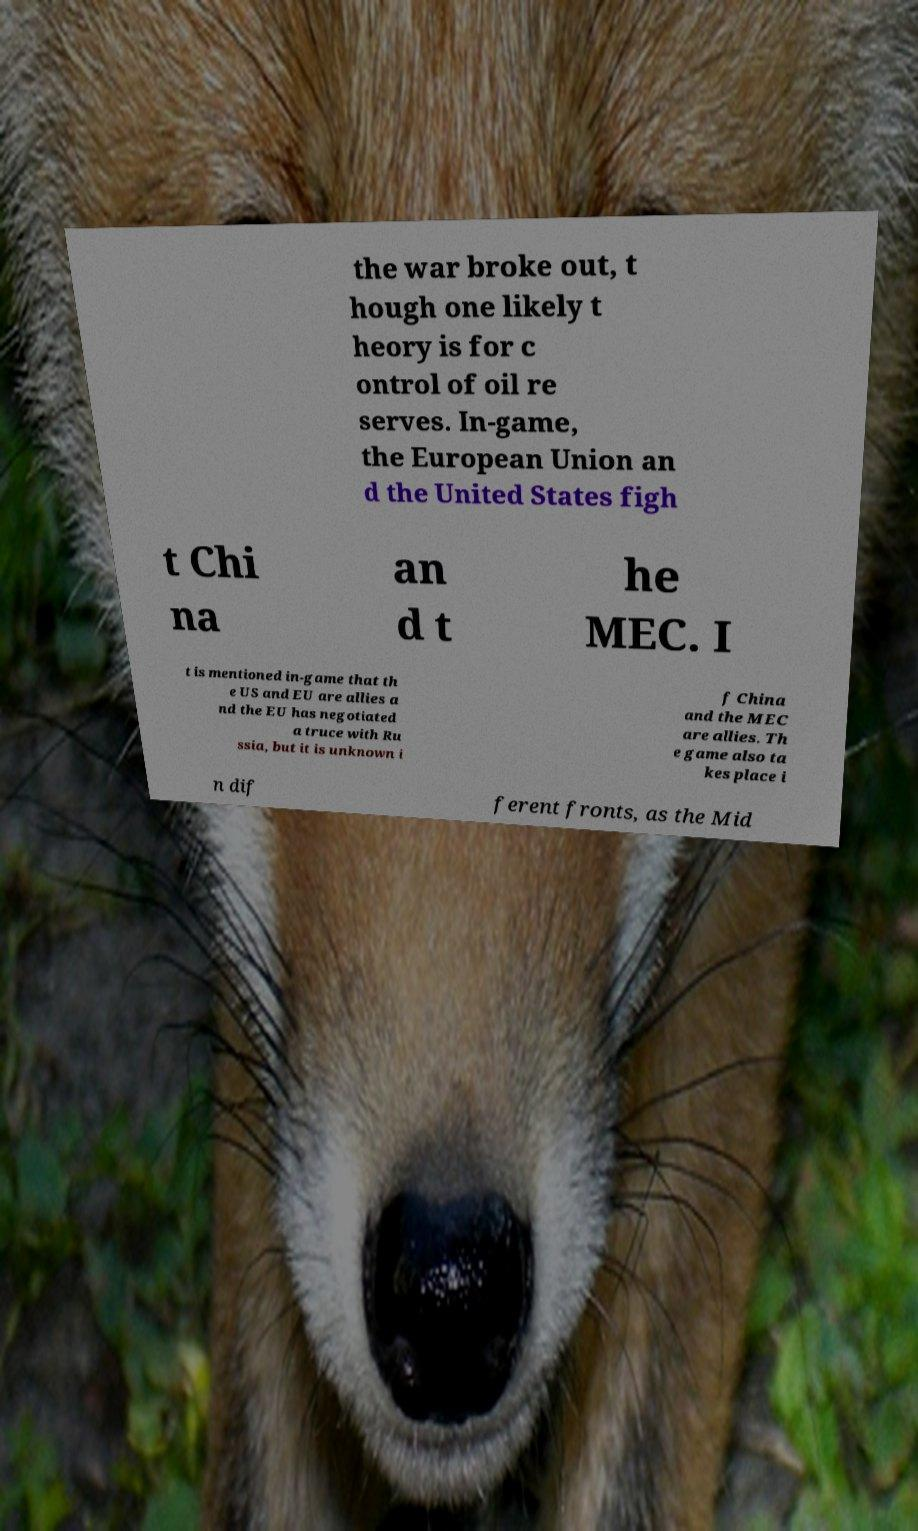For documentation purposes, I need the text within this image transcribed. Could you provide that? the war broke out, t hough one likely t heory is for c ontrol of oil re serves. In-game, the European Union an d the United States figh t Chi na an d t he MEC. I t is mentioned in-game that th e US and EU are allies a nd the EU has negotiated a truce with Ru ssia, but it is unknown i f China and the MEC are allies. Th e game also ta kes place i n dif ferent fronts, as the Mid 